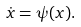Convert formula to latex. <formula><loc_0><loc_0><loc_500><loc_500>\dot { x } = \psi ( x ) .</formula> 